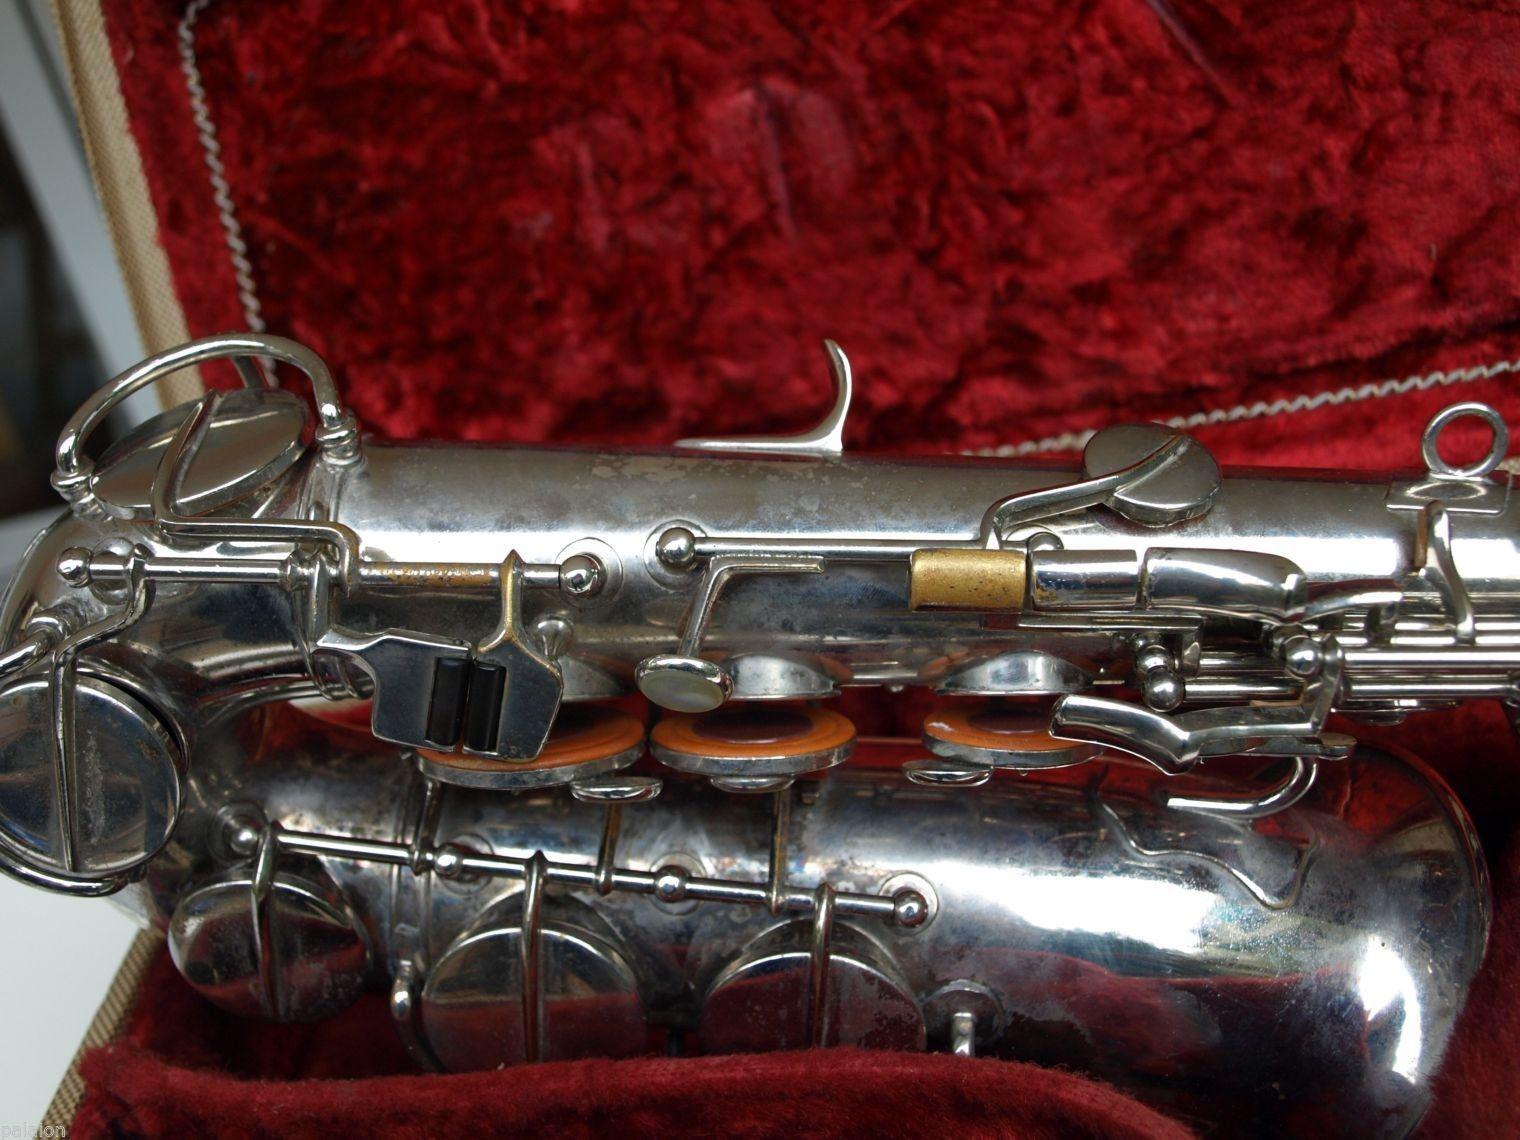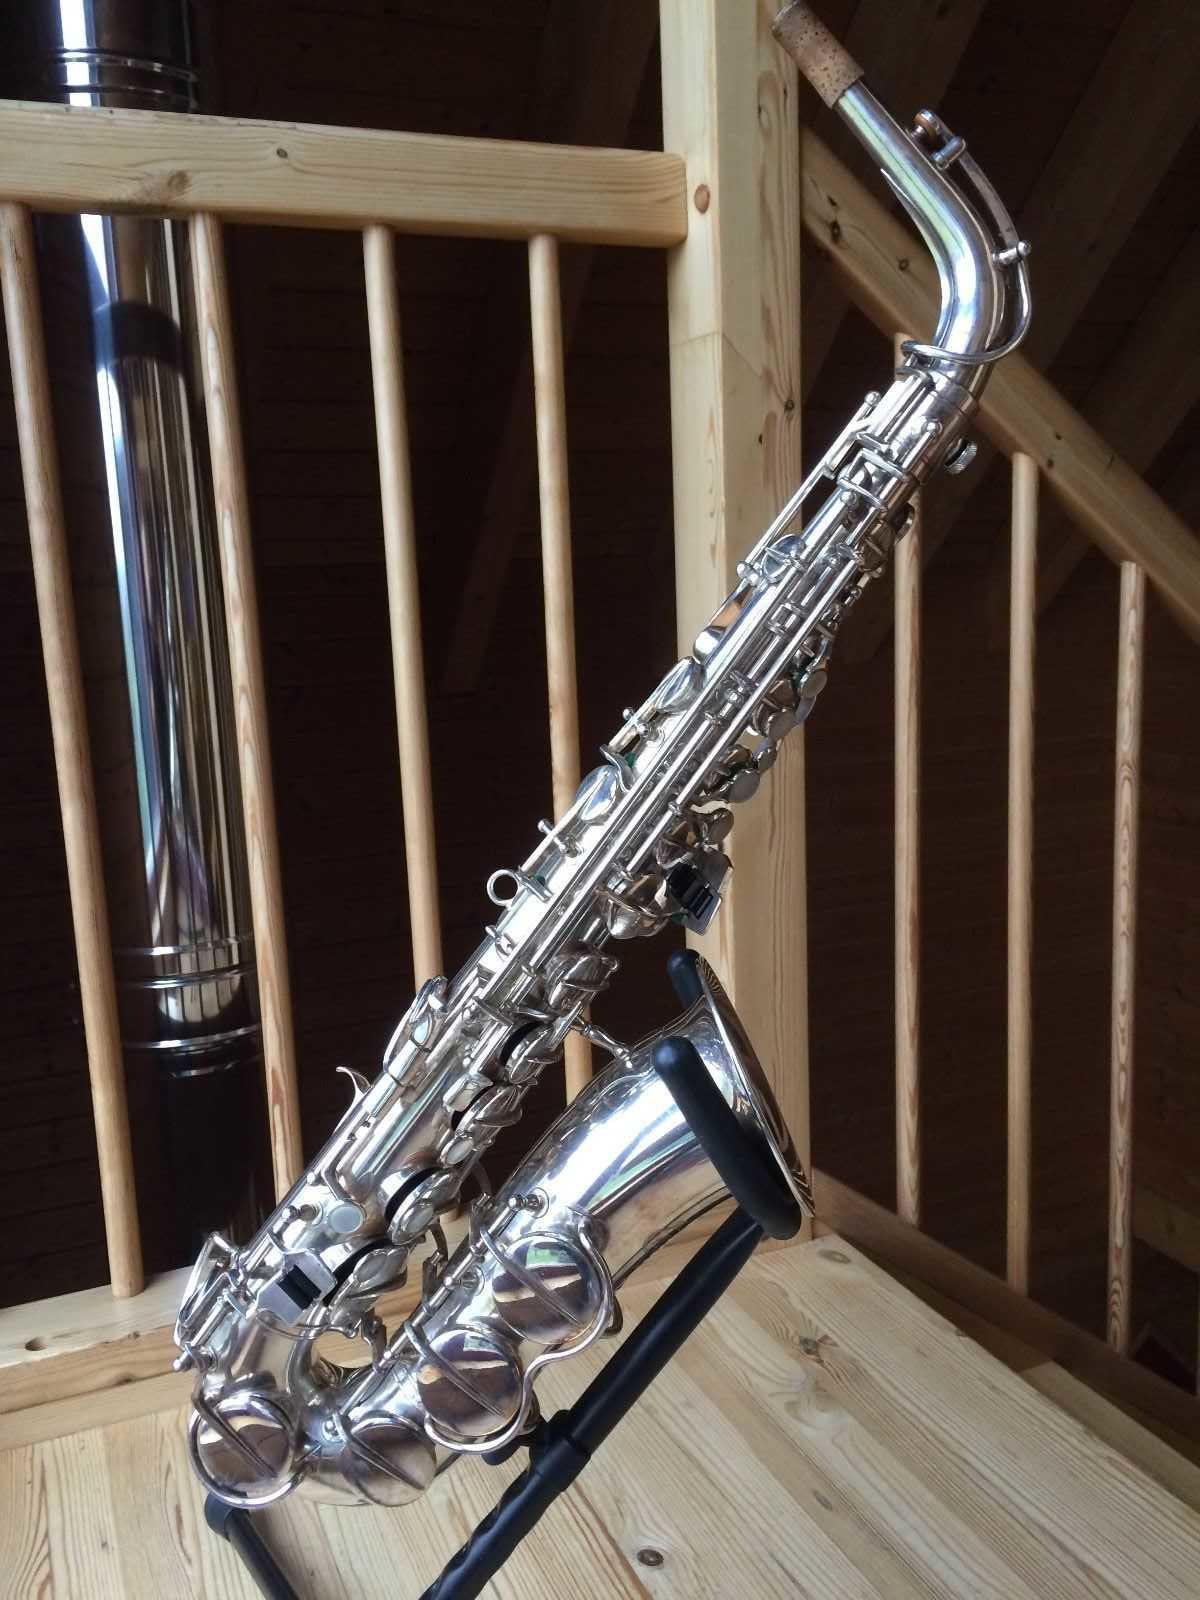The first image is the image on the left, the second image is the image on the right. For the images displayed, is the sentence "In one image, a full length saxophone is lying flat on a cloth, while a second image shows only the lower section of a silver saxophone." factually correct? Answer yes or no. No. The first image is the image on the left, the second image is the image on the right. Given the left and right images, does the statement "An image shows a silver saxophone in an open case lined with crushed red velvet." hold true? Answer yes or no. Yes. 